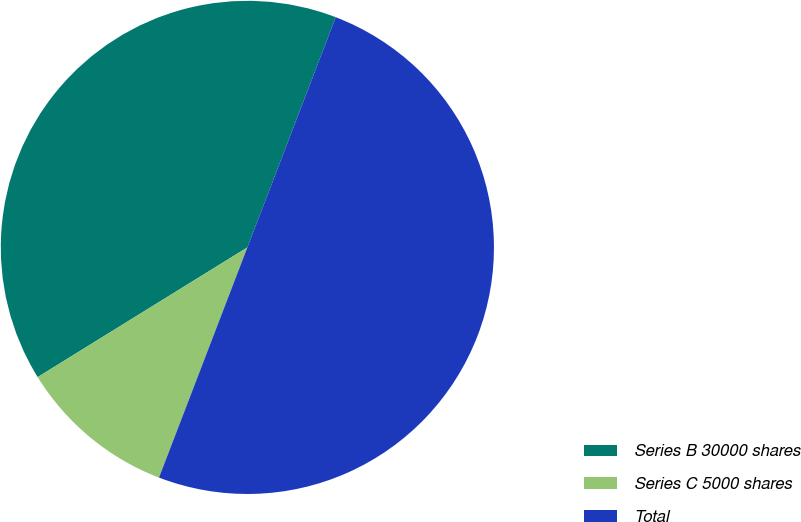Convert chart to OTSL. <chart><loc_0><loc_0><loc_500><loc_500><pie_chart><fcel>Series B 30000 shares<fcel>Series C 5000 shares<fcel>Total<nl><fcel>39.65%<fcel>10.35%<fcel>50.0%<nl></chart> 